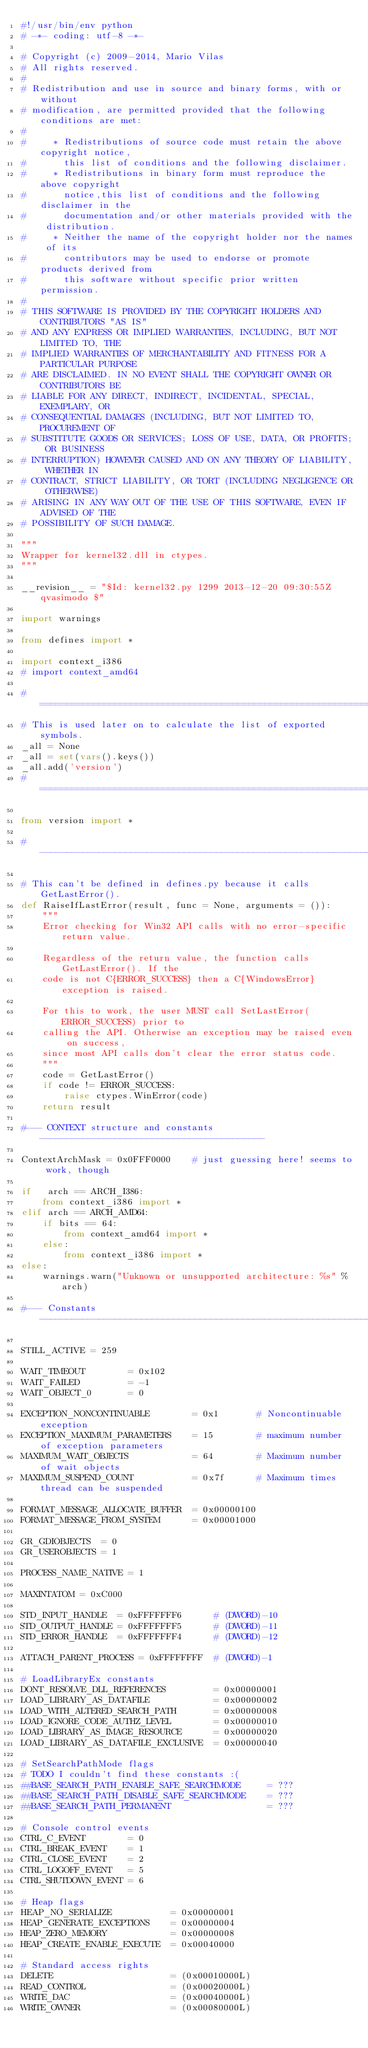<code> <loc_0><loc_0><loc_500><loc_500><_Python_>#!/usr/bin/env python
# -*- coding: utf-8 -*-

# Copyright (c) 2009-2014, Mario Vilas
# All rights reserved.
#
# Redistribution and use in source and binary forms, with or without
# modification, are permitted provided that the following conditions are met:
#
#     * Redistributions of source code must retain the above copyright notice,
#       this list of conditions and the following disclaimer.
#     * Redistributions in binary form must reproduce the above copyright
#       notice,this list of conditions and the following disclaimer in the
#       documentation and/or other materials provided with the distribution.
#     * Neither the name of the copyright holder nor the names of its
#       contributors may be used to endorse or promote products derived from
#       this software without specific prior written permission.
#
# THIS SOFTWARE IS PROVIDED BY THE COPYRIGHT HOLDERS AND CONTRIBUTORS "AS IS"
# AND ANY EXPRESS OR IMPLIED WARRANTIES, INCLUDING, BUT NOT LIMITED TO, THE
# IMPLIED WARRANTIES OF MERCHANTABILITY AND FITNESS FOR A PARTICULAR PURPOSE
# ARE DISCLAIMED. IN NO EVENT SHALL THE COPYRIGHT OWNER OR CONTRIBUTORS BE
# LIABLE FOR ANY DIRECT, INDIRECT, INCIDENTAL, SPECIAL, EXEMPLARY, OR
# CONSEQUENTIAL DAMAGES (INCLUDING, BUT NOT LIMITED TO, PROCUREMENT OF
# SUBSTITUTE GOODS OR SERVICES; LOSS OF USE, DATA, OR PROFITS; OR BUSINESS
# INTERRUPTION) HOWEVER CAUSED AND ON ANY THEORY OF LIABILITY, WHETHER IN
# CONTRACT, STRICT LIABILITY, OR TORT (INCLUDING NEGLIGENCE OR OTHERWISE)
# ARISING IN ANY WAY OUT OF THE USE OF THIS SOFTWARE, EVEN IF ADVISED OF THE
# POSSIBILITY OF SUCH DAMAGE.

"""
Wrapper for kernel32.dll in ctypes.
"""

__revision__ = "$Id: kernel32.py 1299 2013-12-20 09:30:55Z qvasimodo $"

import warnings

from defines import *

import context_i386
# import context_amd64

#==============================================================================
# This is used later on to calculate the list of exported symbols.
_all = None
_all = set(vars().keys())
_all.add('version')
#==============================================================================

from version import *

#------------------------------------------------------------------------------

# This can't be defined in defines.py because it calls GetLastError().
def RaiseIfLastError(result, func = None, arguments = ()):
    """
    Error checking for Win32 API calls with no error-specific return value.

    Regardless of the return value, the function calls GetLastError(). If the
    code is not C{ERROR_SUCCESS} then a C{WindowsError} exception is raised.

    For this to work, the user MUST call SetLastError(ERROR_SUCCESS) prior to
    calling the API. Otherwise an exception may be raised even on success,
    since most API calls don't clear the error status code.
    """
    code = GetLastError()
    if code != ERROR_SUCCESS:
        raise ctypes.WinError(code)
    return result

#--- CONTEXT structure and constants ------------------------------------------

ContextArchMask = 0x0FFF0000    # just guessing here! seems to work, though

if   arch == ARCH_I386:
    from context_i386 import *
elif arch == ARCH_AMD64:
    if bits == 64:
        from context_amd64 import *
    else:
        from context_i386 import *
else:
    warnings.warn("Unknown or unsupported architecture: %s" % arch)

#--- Constants ----------------------------------------------------------------

STILL_ACTIVE = 259

WAIT_TIMEOUT        = 0x102
WAIT_FAILED         = -1
WAIT_OBJECT_0       = 0

EXCEPTION_NONCONTINUABLE        = 0x1       # Noncontinuable exception
EXCEPTION_MAXIMUM_PARAMETERS    = 15        # maximum number of exception parameters
MAXIMUM_WAIT_OBJECTS            = 64        # Maximum number of wait objects
MAXIMUM_SUSPEND_COUNT           = 0x7f      # Maximum times thread can be suspended

FORMAT_MESSAGE_ALLOCATE_BUFFER  = 0x00000100
FORMAT_MESSAGE_FROM_SYSTEM      = 0x00001000

GR_GDIOBJECTS  = 0
GR_USEROBJECTS = 1

PROCESS_NAME_NATIVE = 1

MAXINTATOM = 0xC000

STD_INPUT_HANDLE  = 0xFFFFFFF6      # (DWORD)-10
STD_OUTPUT_HANDLE = 0xFFFFFFF5      # (DWORD)-11
STD_ERROR_HANDLE  = 0xFFFFFFF4      # (DWORD)-12

ATTACH_PARENT_PROCESS = 0xFFFFFFFF  # (DWORD)-1

# LoadLibraryEx constants
DONT_RESOLVE_DLL_REFERENCES         = 0x00000001
LOAD_LIBRARY_AS_DATAFILE            = 0x00000002
LOAD_WITH_ALTERED_SEARCH_PATH       = 0x00000008
LOAD_IGNORE_CODE_AUTHZ_LEVEL        = 0x00000010
LOAD_LIBRARY_AS_IMAGE_RESOURCE      = 0x00000020
LOAD_LIBRARY_AS_DATAFILE_EXCLUSIVE  = 0x00000040

# SetSearchPathMode flags
# TODO I couldn't find these constants :(
##BASE_SEARCH_PATH_ENABLE_SAFE_SEARCHMODE     = ???
##BASE_SEARCH_PATH_DISABLE_SAFE_SEARCHMODE    = ???
##BASE_SEARCH_PATH_PERMANENT                  = ???

# Console control events
CTRL_C_EVENT        = 0
CTRL_BREAK_EVENT    = 1
CTRL_CLOSE_EVENT    = 2
CTRL_LOGOFF_EVENT   = 5
CTRL_SHUTDOWN_EVENT = 6

# Heap flags
HEAP_NO_SERIALIZE           = 0x00000001
HEAP_GENERATE_EXCEPTIONS    = 0x00000004
HEAP_ZERO_MEMORY            = 0x00000008
HEAP_CREATE_ENABLE_EXECUTE  = 0x00040000

# Standard access rights
DELETE                      = (0x00010000L)
READ_CONTROL                = (0x00020000L)
WRITE_DAC                   = (0x00040000L)
WRITE_OWNER                 = (0x00080000L)</code> 